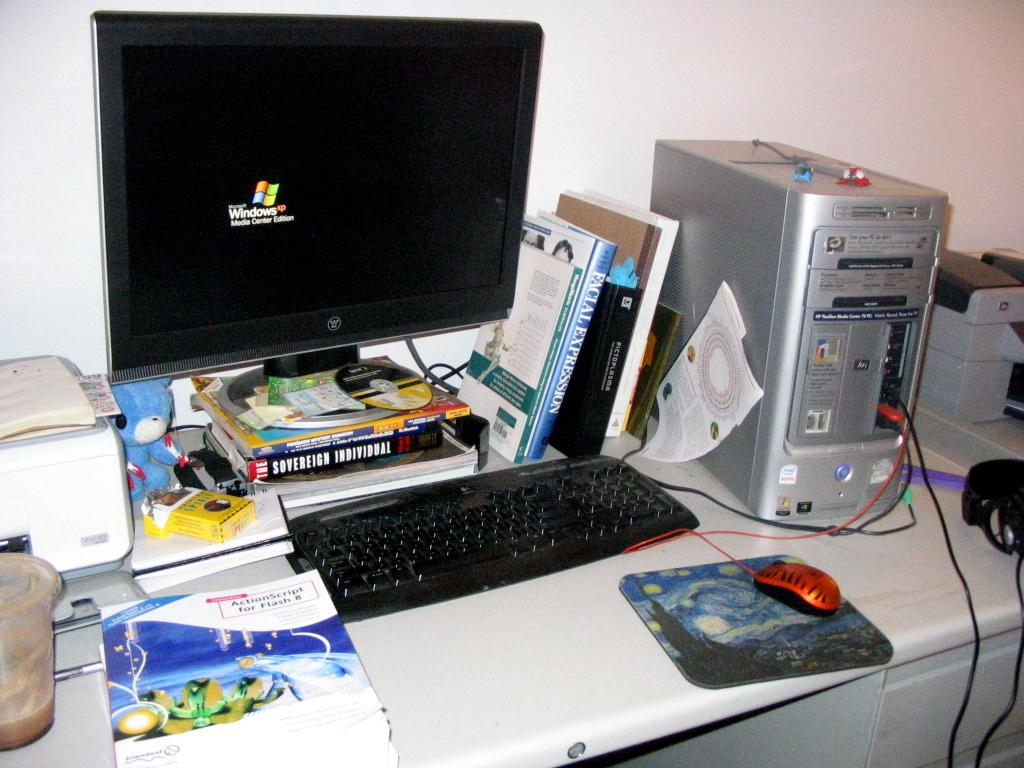<image>
Summarize the visual content of the image. A book with a title cover that reads ActionScript for Flash 8. 